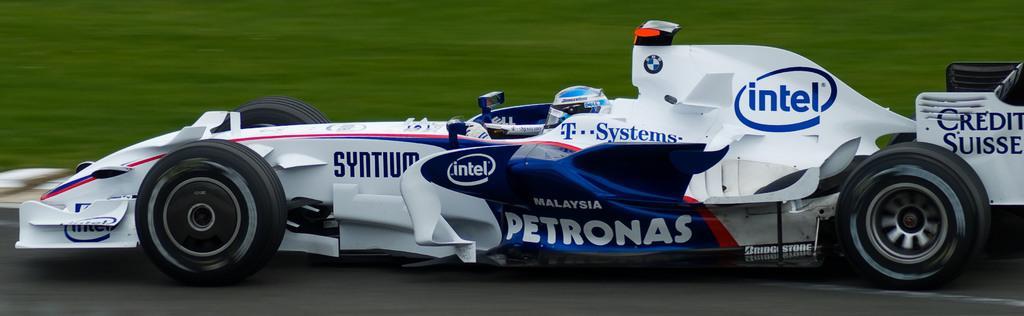How would you summarize this image in a sentence or two? In this image, we can see a car. There is a person in the middle of the image. 